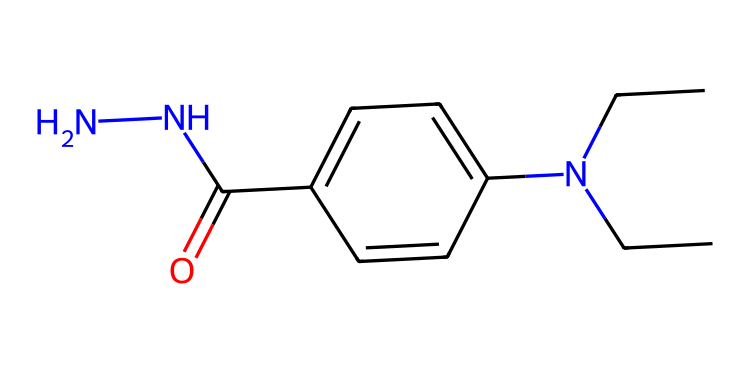How many nitrogen atoms are present in this molecule? The SMILES representation includes "N" several times, indicating the presence of nitrogen atoms. By counting the "N" in the SMILES, we determine there are two nitrogen atoms in total.
Answer: two What is the functional group in this chemical? The SMILES contains "C(=O)", which indicates a carbon atom (C) double-bonded to an oxygen atom (O), characteristic of a carbonyl group. This suggests the presence of an amide functional group since it is bonded to nitrogen.
Answer: amide How many carbon atoms are present in this molecule? By analyzing the SMILES, we count the total number of "C" characters present. The structure shows six carbon atoms in total when accounting for all the indicated carbon atoms.
Answer: six What type of bonding is primarily present in this chemical structure? The structure has multiple single bonds represented between carbon and nitrogen atoms, along with a double bond between carbon and oxygen, indicating the chemical has covalent bonding throughout its structure.
Answer: covalent Is this chemical likely to be hydrophilic or hydrophobic? The presence of nitrogen and oxygen atoms suggests the molecule can interact with water through hydrogen bonding, implying it's more hydrophilic than hydrophobic.
Answer: hydrophilic What does the branching in the carbon chain indicate about the structure? The branching in the carbon chain, such as N(CC)CC, suggests that there are substituents on the main carbon chain which can influence the chemical’s solubility and reactivity.
Answer: substituents 